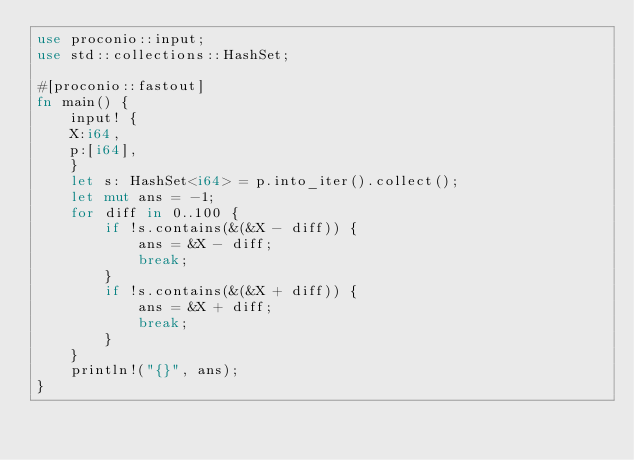<code> <loc_0><loc_0><loc_500><loc_500><_Rust_>use proconio::input;
use std::collections::HashSet;

#[proconio::fastout]
fn main() {
    input! {
    X:i64,
    p:[i64],
    }
    let s: HashSet<i64> = p.into_iter().collect();
    let mut ans = -1;
    for diff in 0..100 {
        if !s.contains(&(&X - diff)) {
            ans = &X - diff;
            break;
        }
        if !s.contains(&(&X + diff)) {
            ans = &X + diff;
            break;
        }
    }
    println!("{}", ans);
}
</code> 